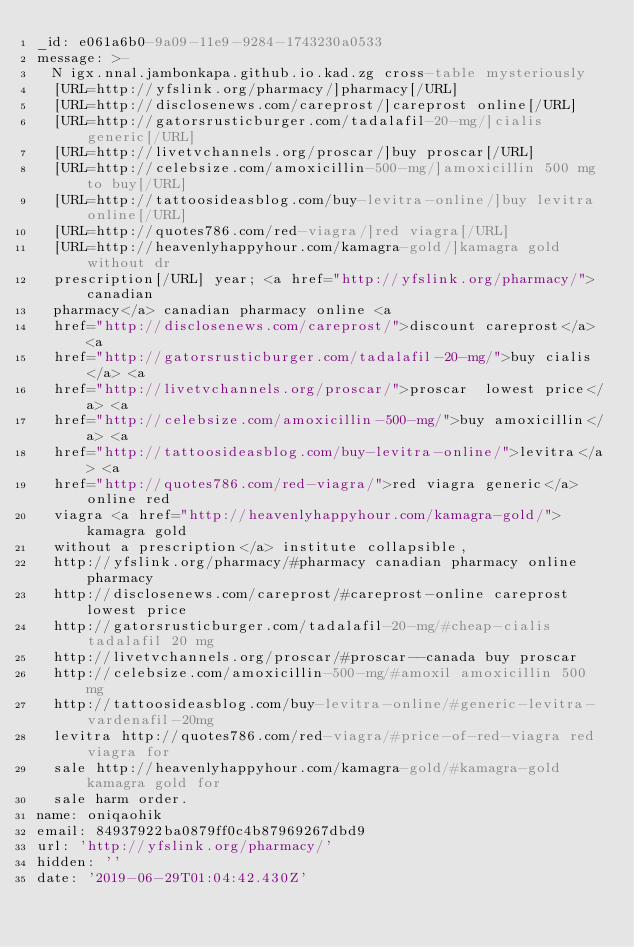<code> <loc_0><loc_0><loc_500><loc_500><_YAML_>_id: e061a6b0-9a09-11e9-9284-1743230a0533
message: >-
  N igx.nnal.jambonkapa.github.io.kad.zg cross-table mysteriously
  [URL=http://yfslink.org/pharmacy/]pharmacy[/URL]
  [URL=http://disclosenews.com/careprost/]careprost online[/URL]
  [URL=http://gatorsrusticburger.com/tadalafil-20-mg/]cialis generic[/URL]
  [URL=http://livetvchannels.org/proscar/]buy proscar[/URL]
  [URL=http://celebsize.com/amoxicillin-500-mg/]amoxicillin 500 mg to buy[/URL]
  [URL=http://tattoosideasblog.com/buy-levitra-online/]buy levitra online[/URL]
  [URL=http://quotes786.com/red-viagra/]red viagra[/URL]
  [URL=http://heavenlyhappyhour.com/kamagra-gold/]kamagra gold without dr
  prescription[/URL] year; <a href="http://yfslink.org/pharmacy/">canadian
  pharmacy</a> canadian pharmacy online <a
  href="http://disclosenews.com/careprost/">discount careprost</a> <a
  href="http://gatorsrusticburger.com/tadalafil-20-mg/">buy cialis</a> <a
  href="http://livetvchannels.org/proscar/">proscar  lowest price</a> <a
  href="http://celebsize.com/amoxicillin-500-mg/">buy amoxicillin</a> <a
  href="http://tattoosideasblog.com/buy-levitra-online/">levitra</a> <a
  href="http://quotes786.com/red-viagra/">red viagra generic</a> online red
  viagra <a href="http://heavenlyhappyhour.com/kamagra-gold/">kamagra gold
  without a prescription</a> institute collapsible,
  http://yfslink.org/pharmacy/#pharmacy canadian pharmacy online pharmacy
  http://disclosenews.com/careprost/#careprost-online careprost lowest price
  http://gatorsrusticburger.com/tadalafil-20-mg/#cheap-cialis tadalafil 20 mg
  http://livetvchannels.org/proscar/#proscar--canada buy proscar
  http://celebsize.com/amoxicillin-500-mg/#amoxil amoxicillin 500 mg
  http://tattoosideasblog.com/buy-levitra-online/#generic-levitra-vardenafil-20mg
  levitra http://quotes786.com/red-viagra/#price-of-red-viagra red viagra for
  sale http://heavenlyhappyhour.com/kamagra-gold/#kamagra-gold kamagra gold for
  sale harm order.
name: oniqaohik
email: 84937922ba0879ff0c4b87969267dbd9
url: 'http://yfslink.org/pharmacy/'
hidden: ''
date: '2019-06-29T01:04:42.430Z'
</code> 